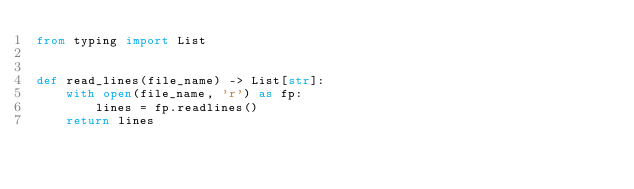<code> <loc_0><loc_0><loc_500><loc_500><_Python_>from typing import List


def read_lines(file_name) -> List[str]:
    with open(file_name, 'r') as fp:
        lines = fp.readlines()
    return lines
</code> 